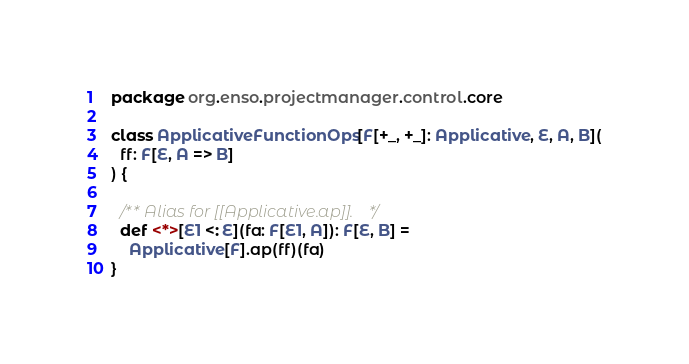Convert code to text. <code><loc_0><loc_0><loc_500><loc_500><_Scala_>package org.enso.projectmanager.control.core

class ApplicativeFunctionOps[F[+_, +_]: Applicative, E, A, B](
  ff: F[E, A => B]
) {

  /** Alias for [[Applicative.ap]]. */
  def <*>[E1 <: E](fa: F[E1, A]): F[E, B] =
    Applicative[F].ap(ff)(fa)
}
</code> 